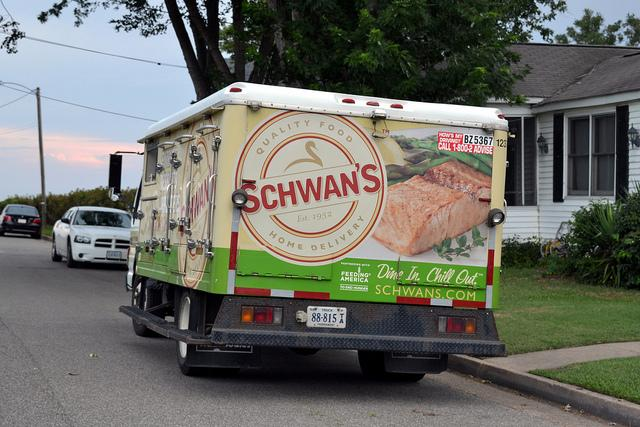How does the it feel inside the back of the truck? Please explain your reasoning. cold. The truck is cold. 